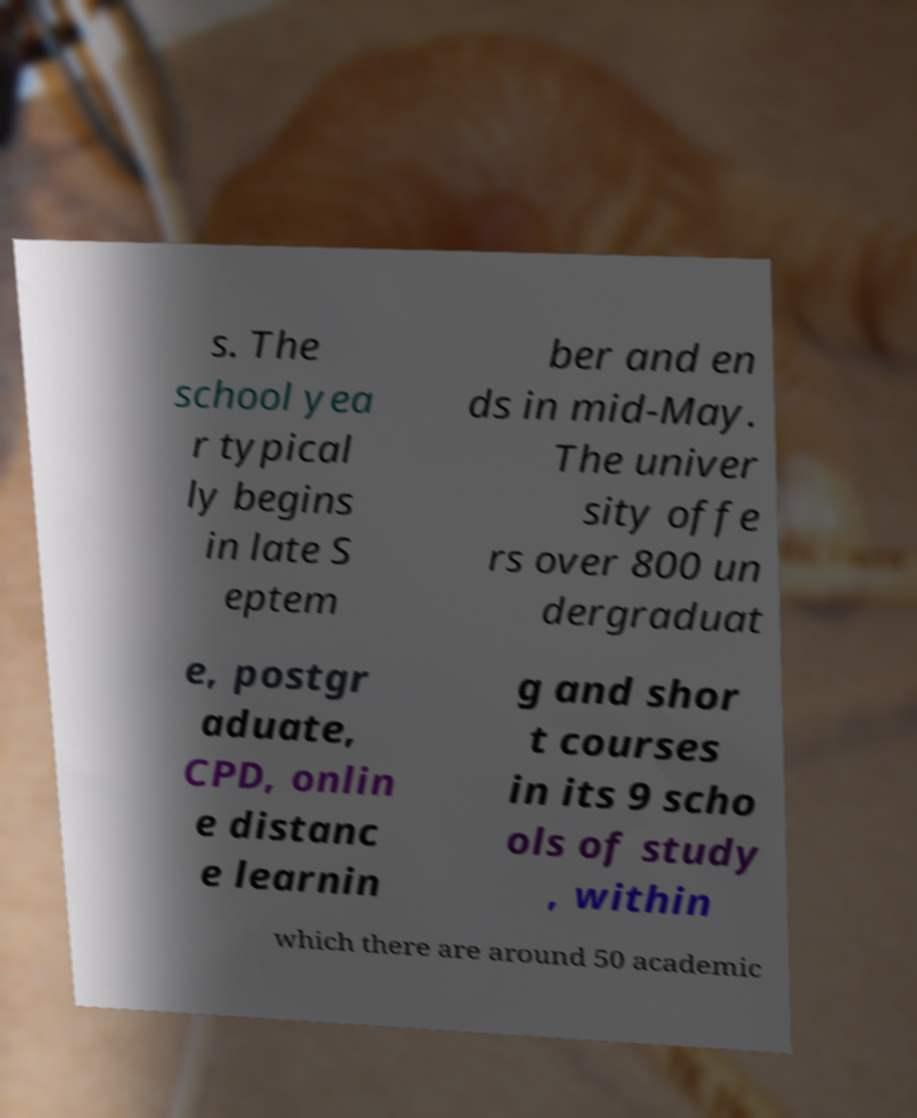Could you extract and type out the text from this image? s. The school yea r typical ly begins in late S eptem ber and en ds in mid-May. The univer sity offe rs over 800 un dergraduat e, postgr aduate, CPD, onlin e distanc e learnin g and shor t courses in its 9 scho ols of study , within which there are around 50 academic 